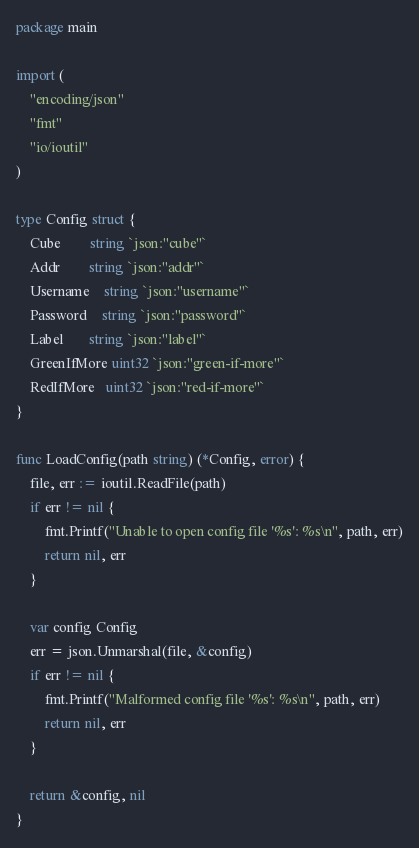Convert code to text. <code><loc_0><loc_0><loc_500><loc_500><_Go_>package main

import (
	"encoding/json"
	"fmt"
	"io/ioutil"
)

type Config struct {
	Cube        string `json:"cube"`
	Addr        string `json:"addr"`
	Username    string `json:"username"`
	Password    string `json:"password"`
	Label       string `json:"label"`
	GreenIfMore uint32 `json:"green-if-more"`
	RedIfMore   uint32 `json:"red-if-more"`
}

func LoadConfig(path string) (*Config, error) {
	file, err := ioutil.ReadFile(path)
	if err != nil {
		fmt.Printf("Unable to open config file '%s': %s\n", path, err)
		return nil, err
	}

	var config Config
	err = json.Unmarshal(file, &config)
	if err != nil {
		fmt.Printf("Malformed config file '%s': %s\n", path, err)
		return nil, err
	}

	return &config, nil
}
</code> 